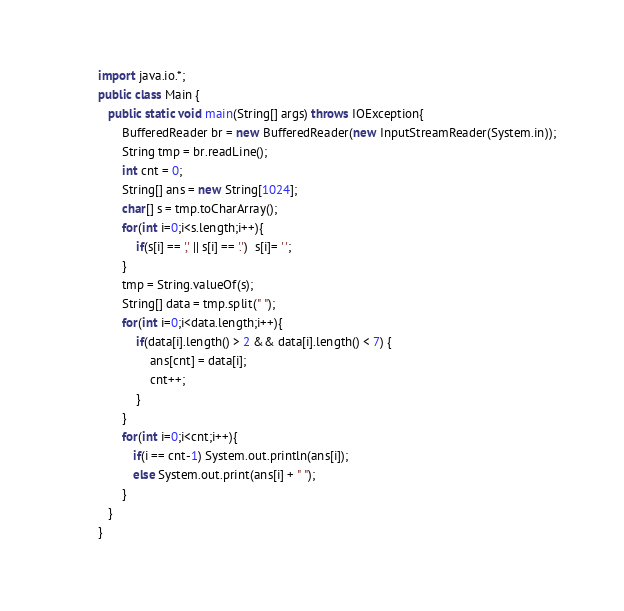<code> <loc_0><loc_0><loc_500><loc_500><_Java_>import java.io.*;
public class Main {
   public static void main(String[] args) throws IOException{
       BufferedReader br = new BufferedReader(new InputStreamReader(System.in));
       String tmp = br.readLine();
       int cnt = 0;
       String[] ans = new String[1024];
       char[] s = tmp.toCharArray();
       for(int i=0;i<s.length;i++){
           if(s[i] == ',' || s[i] == '.')  s[i]= ' ';
       }
       tmp = String.valueOf(s);
       String[] data = tmp.split(" ");
       for(int i=0;i<data.length;i++){
           if(data[i].length() > 2 && data[i].length() < 7) {
               ans[cnt] = data[i];
               cnt++;
           }
       }
       for(int i=0;i<cnt;i++){
          if(i == cnt-1) System.out.println(ans[i]);
          else System.out.print(ans[i] + " ");
       }
   }
}</code> 